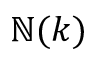<formula> <loc_0><loc_0><loc_500><loc_500>\mathbb { N } ( k )</formula> 